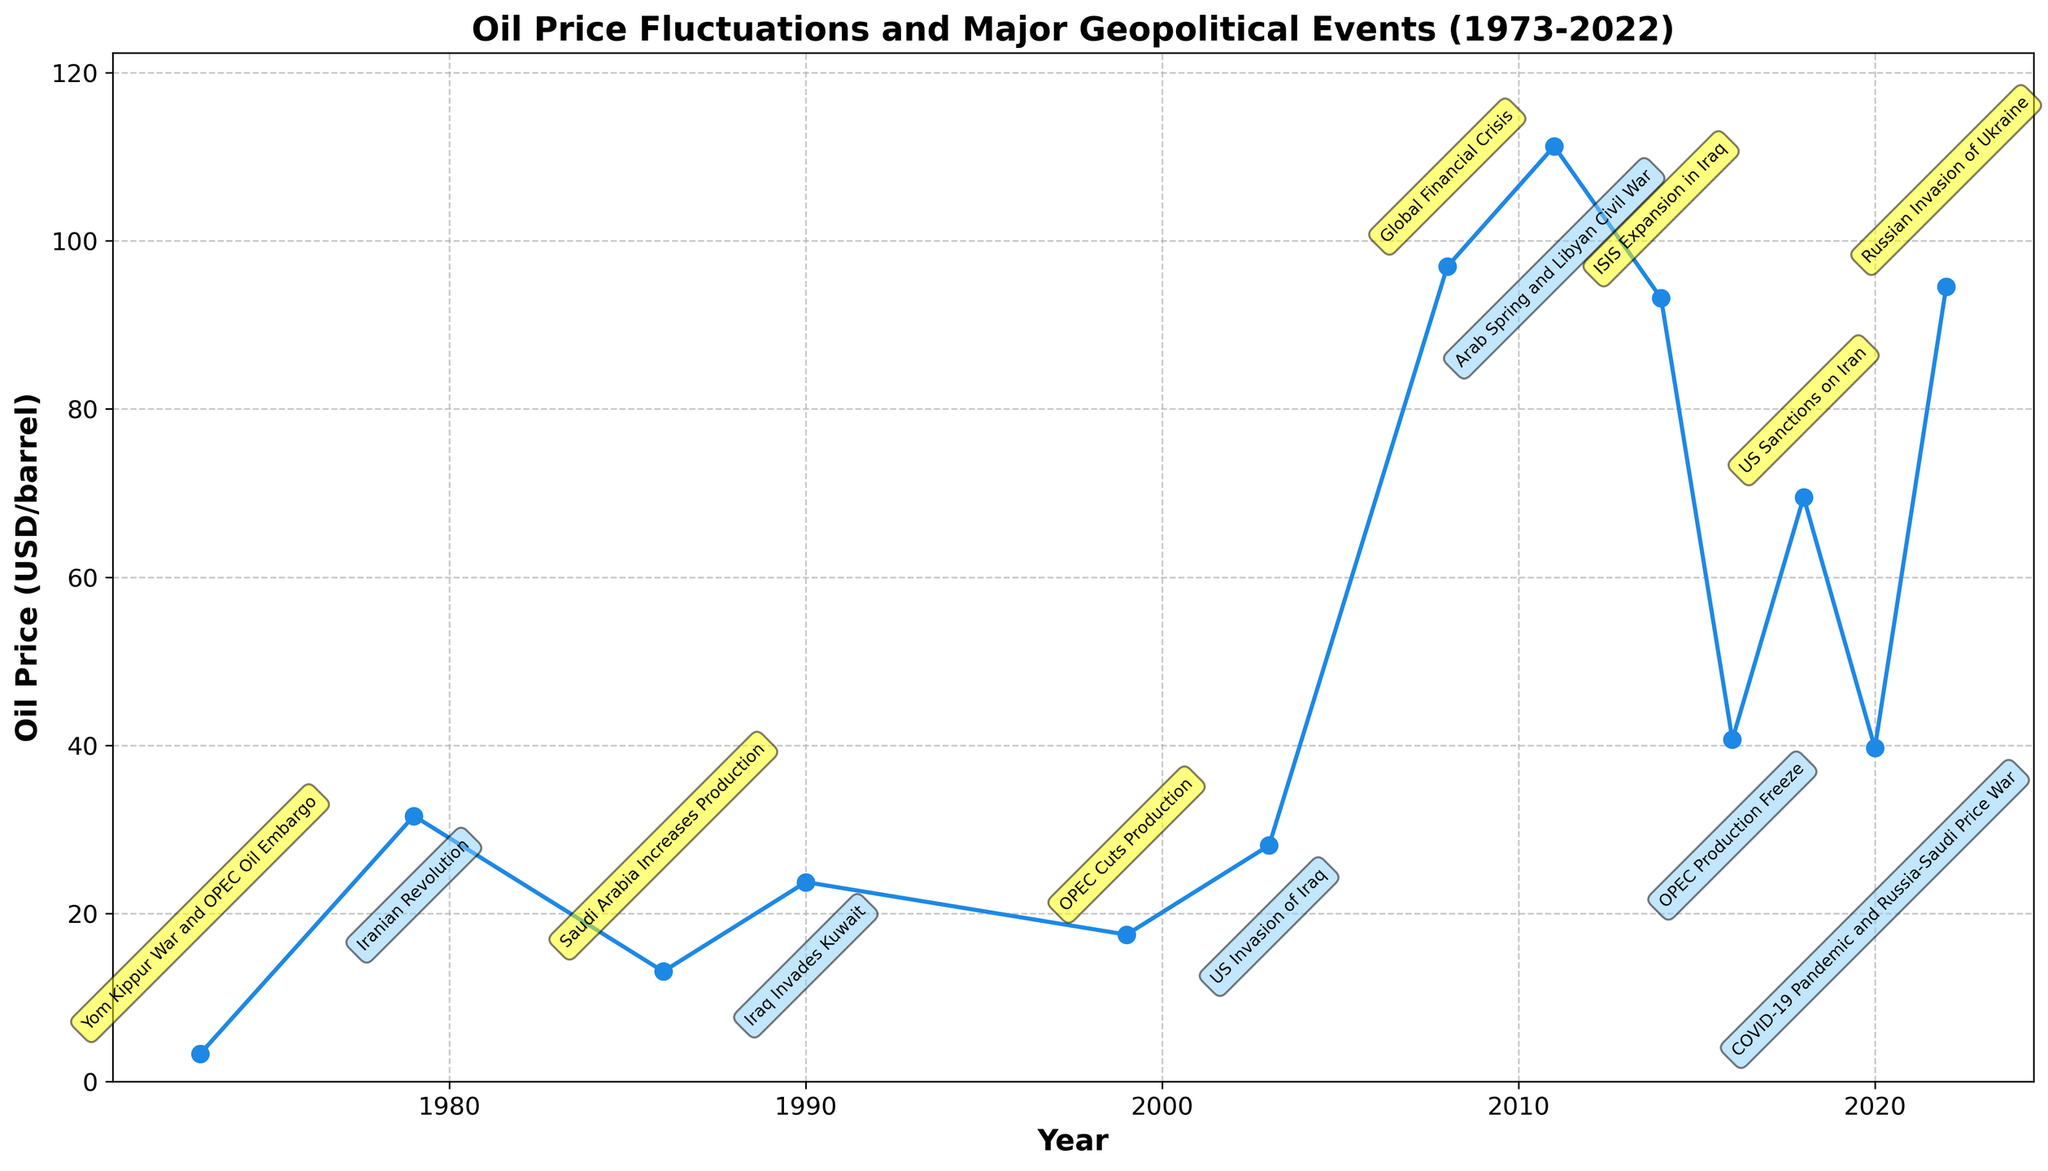What year had the highest oil price? The figure shows the oil prices over the years. By scanning the plot for the highest point, we find that 2011 had the highest oil price at around $111.26 per barrel.
Answer: 2011 How did the oil price change between 1979 and 1986? To determine the change, we look at the oil prices for both years. The price in 1979 was $31.61, and in 1986 it was $13.10. The change is $31.61 - $13.10 = $18.51.
Answer: Decreased by $18.51 Which geopolitical event coincided with the spike in oil prices in 2008? By locating 2008 on the timeline and observing the corresponding annotation, we see that the spike in oil prices coincided with the Global Financial Crisis.
Answer: Global Financial Crisis What is the average oil price over the last 50 years? To find the average, sum the oil prices from 1973 to 2022 and divide by the number of years observed. The sum of the prices is (3.29 + 31.61 + 13.10 + 23.73 + 17.48 + 28.10 + 96.94 + 111.26 + 93.17 + 40.68 + 69.51 + 39.68 + 94.53) = 663.08. There are 13 years of data, so the average is 663.08 / 13 ≈ 51.01.
Answer: Approximately $51.01 What event caused the most significant drop in oil price from one year to the next? By examining the line plot for the steepest decline, we see the largest drop occurred between 2008 and 2014, from $111.26 to $40.68, caused by OPEC's production freeze in 2016. The decline is $111.26 - $40.68 = $70.58.
Answer: OPEC Production Freeze in 2016 How does the oil price in 2022 compare with that in 1986? Comparing the prices from 2022 and 1986 on the plot, the price in 2022 is $94.53 and in 1986 it was $13.10. $94.53 is significantly higher than $13.10, specifically, $94.53 - $13.10 = $81.43 higher.
Answer: $81.43 higher Which year had the lowest oil price, and what event occurred that year? The plot shows that the lowest oil price was in 1973, at $3.29 per barrel. The event that year was the Yom Kippur War and OPEC Oil Embargo.
Answer: 1973, Yom Kippur War and OPEC Oil Embargo How does the oil price fluctuation in the 1970s compare to that in the 2010s? In the 1970s, there were significant fluctuations, with prices spiking from $3.29 in 1973 to $31.61 in 1979. In the 2010s, prices also fluctuated but started from $96.94 in 2008, peaking at $111.26 in 2011, and then dropping to as low as $40.68 in 2016. Both decades experienced substantial fluctuations, but the absolute price level was much higher in the 2010s.
Answer: Significant fluctuations in both, but higher levels in the 2010s What was the percentage increase in oil price from 1999 to 2008? The oil price in 1999 was $17.48, and in 2008 it was $96.94. The percentage increase is calculated as ((96.94 - 17.48) / 17.48) * 100 = approximately 454.75%.
Answer: Approximately 454.75% Which event in the 1990s resulted in a notable change in oil prices? The only event noted in the 1990s on the plot is "OPEC Cuts Production" in 1999, which corresponds to a significant change in oil prices.
Answer: OPEC Cuts Production in 1999 